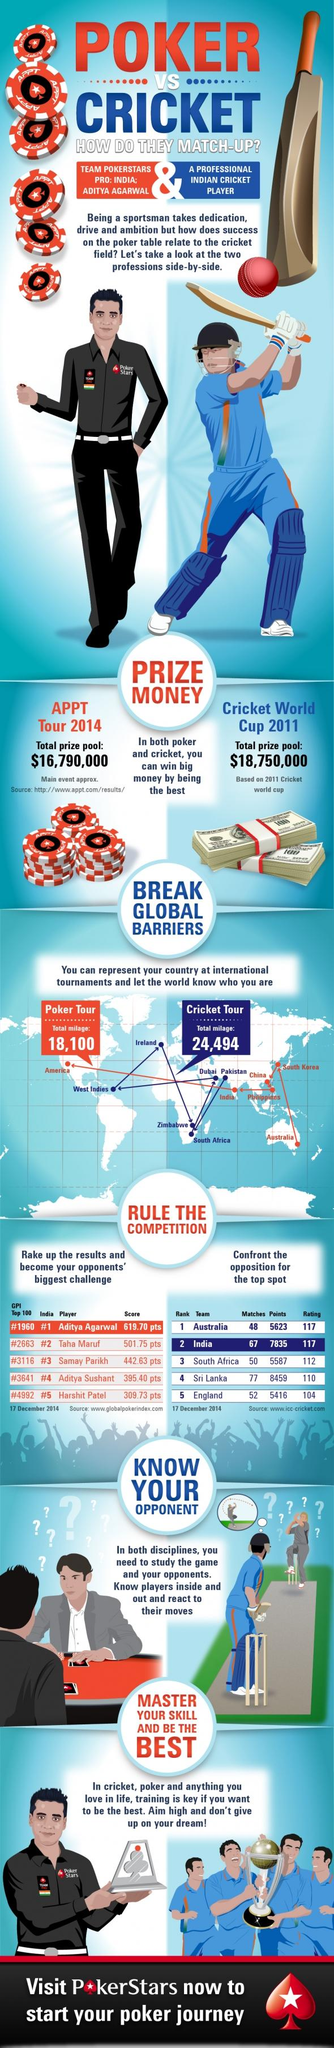Point out several critical features in this image. On December 17, 2014, Australia had the top ICC ranking. As of December 17, 2014, Sri Lanka's ICC rating was 110. As of December 17, 2014, Taha Maruf is the best Indian poker player after Aditya Agarwal. As of December 17, 2014, the total number of match points scored by India was 7,835. The total prize pool for the 2011 Cricket World Cup was $18,750,000. 